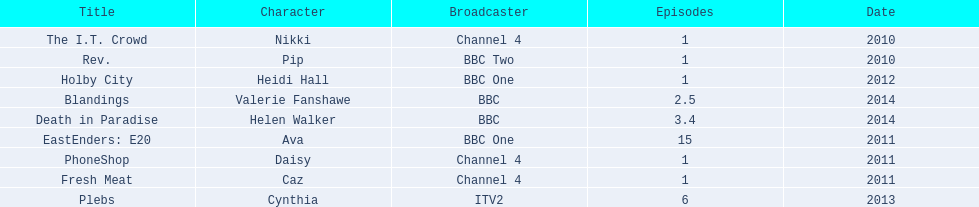How many titles only had one episode? 5. 